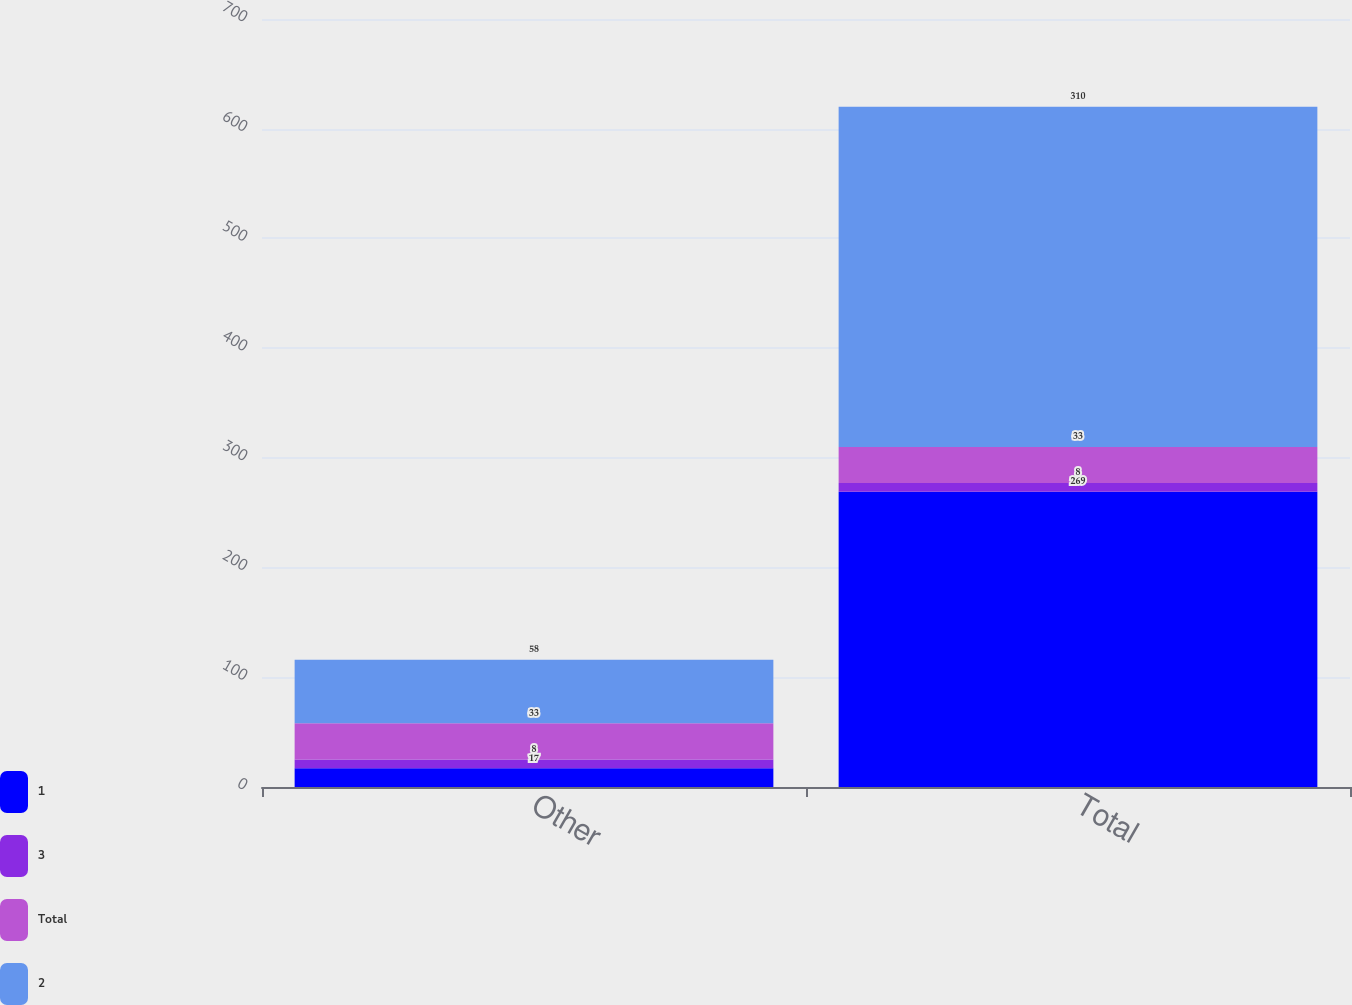<chart> <loc_0><loc_0><loc_500><loc_500><stacked_bar_chart><ecel><fcel>Other<fcel>Total<nl><fcel>1<fcel>17<fcel>269<nl><fcel>3<fcel>8<fcel>8<nl><fcel>Total<fcel>33<fcel>33<nl><fcel>2<fcel>58<fcel>310<nl></chart> 